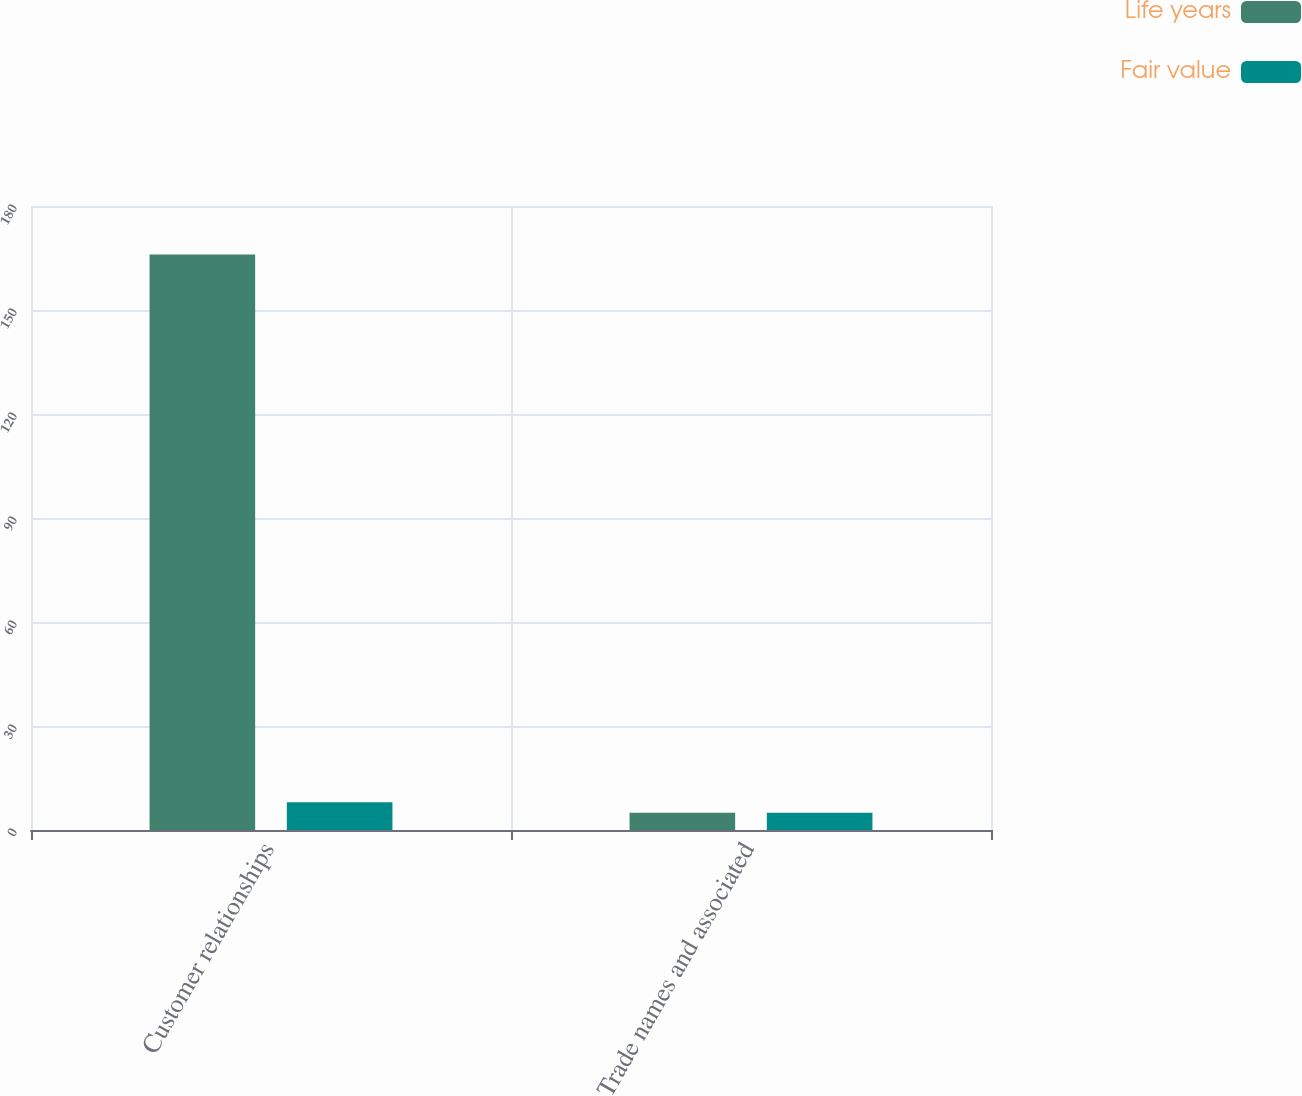Convert chart. <chart><loc_0><loc_0><loc_500><loc_500><stacked_bar_chart><ecel><fcel>Customer relationships<fcel>Trade names and associated<nl><fcel>Life years<fcel>166<fcel>5<nl><fcel>Fair value<fcel>8<fcel>5<nl></chart> 